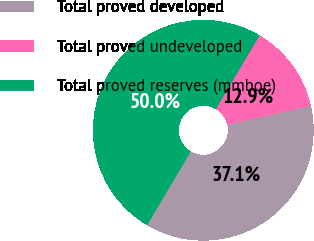<chart> <loc_0><loc_0><loc_500><loc_500><pie_chart><fcel>Total proved developed<fcel>Total proved undeveloped<fcel>Total proved reserves (mmboe)<nl><fcel>37.1%<fcel>12.9%<fcel>50.0%<nl></chart> 